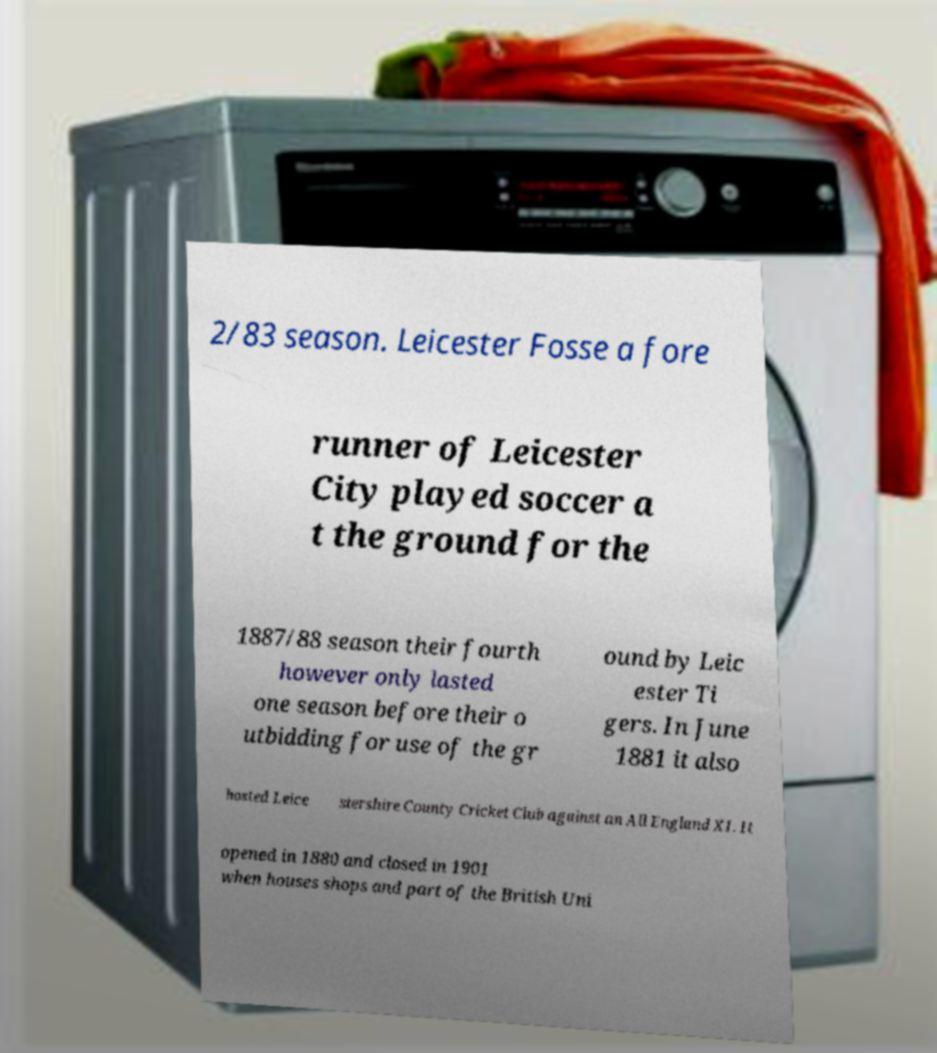Could you extract and type out the text from this image? 2/83 season. Leicester Fosse a fore runner of Leicester City played soccer a t the ground for the 1887/88 season their fourth however only lasted one season before their o utbidding for use of the gr ound by Leic ester Ti gers. In June 1881 it also hosted Leice stershire County Cricket Club against an All England XI. It opened in 1880 and closed in 1901 when houses shops and part of the British Uni 